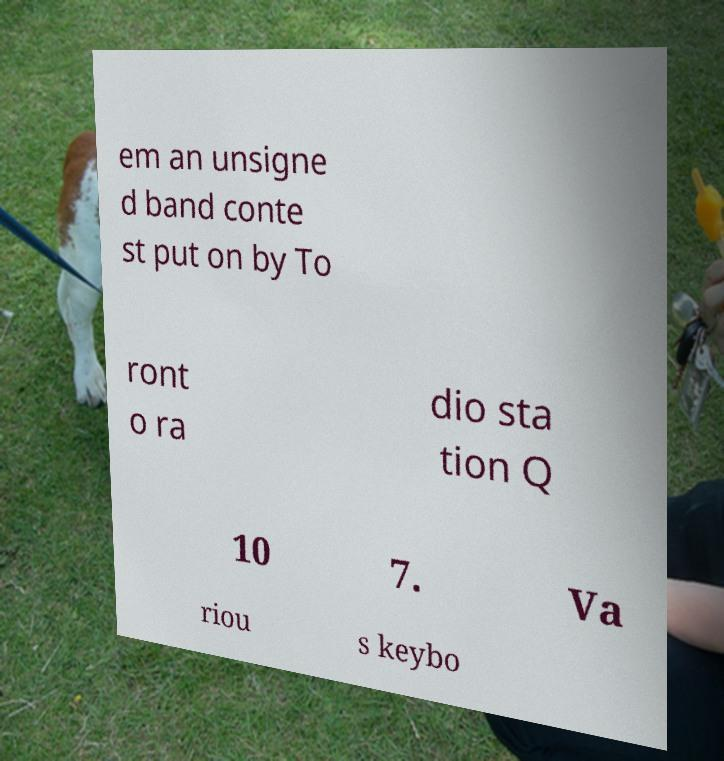Please identify and transcribe the text found in this image. em an unsigne d band conte st put on by To ront o ra dio sta tion Q 10 7. Va riou s keybo 